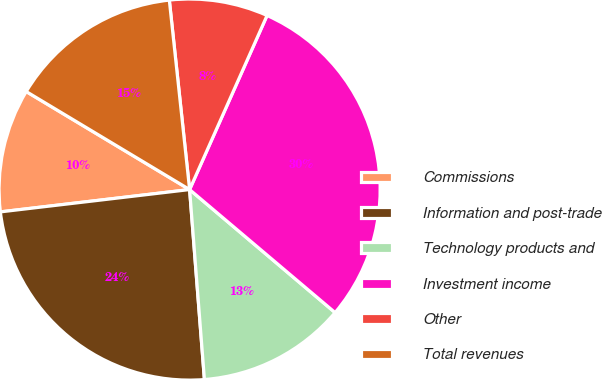Convert chart to OTSL. <chart><loc_0><loc_0><loc_500><loc_500><pie_chart><fcel>Commissions<fcel>Information and post-trade<fcel>Technology products and<fcel>Investment income<fcel>Other<fcel>Total revenues<nl><fcel>10.47%<fcel>24.37%<fcel>12.59%<fcel>29.51%<fcel>8.36%<fcel>14.7%<nl></chart> 